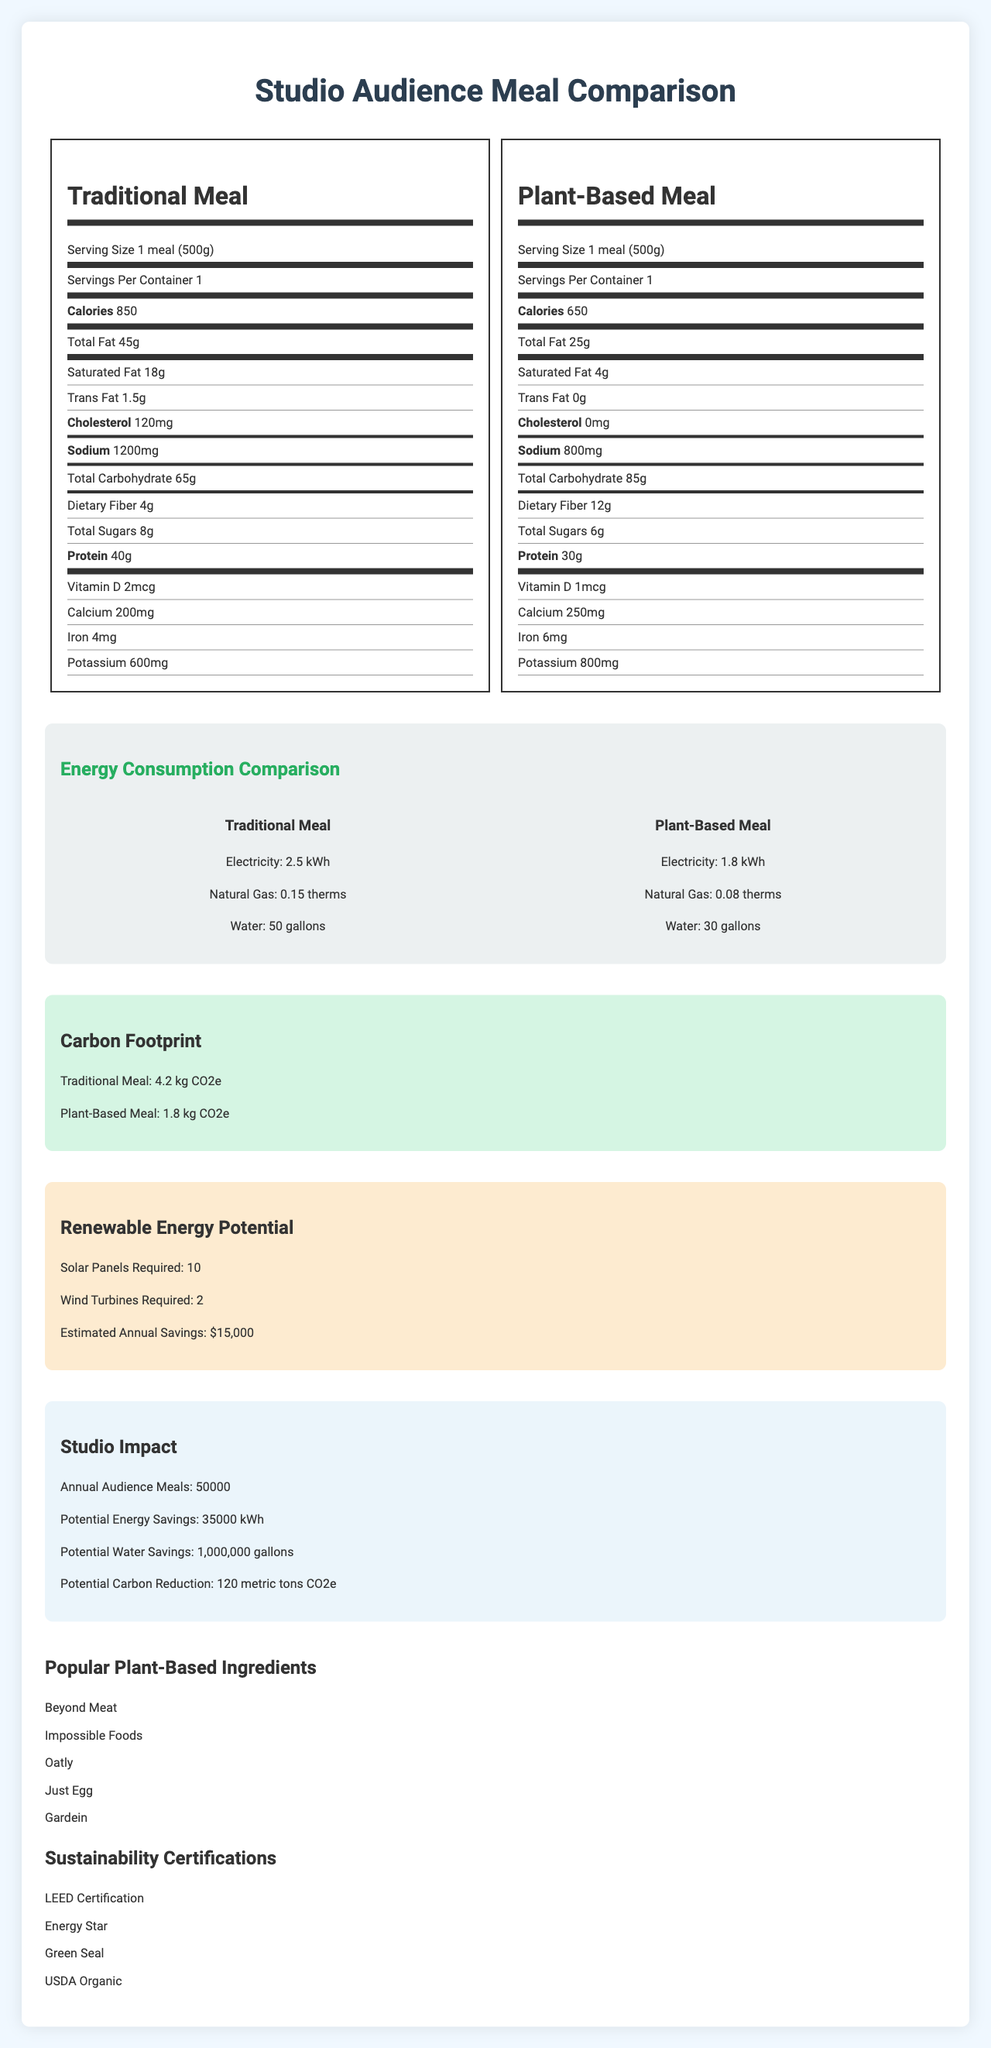what is the serving size for both meals? The serving size for both the traditional and plant-based meals is listed as 1 meal (500g) in the nutrition labels.
Answer: 1 meal (500g) how many calories are in the traditional meal? The calorie content for the traditional meal is listed as 850 in the nutrition label.
Answer: 850 how much sodium is in the plant-based meal? The plant-based meal contains 800 mg of sodium, as shown in the nutrition label.
Answer: 800 mg what is the carbon footprint of the traditional meal? The carbon footprint of the traditional meal is noted as 4.2 kg CO2e in the carbon footprint section.
Answer: 4.2 kg CO2e how much water is used to produce a traditional meal? The water usage for producing a traditional meal is listed as 50 gallons in the energy consumption comparison.
Answer: 50 gallons what is the total dietary fiber in the plant-based meal? The plant-based meal has a total dietary fiber content of 12 g, as shown on the nutrition label.
Answer: 12 g which meal has higher protein content, and by how much? The traditional meal has 40g of protein, while the plant-based meal has 30g, making the traditional meal higher in protein by 10g.
Answer: Traditional meal, by 10g which certification is not listed among the sustainability certifications? A. LEED Certification B. Energy Star C. Fair Trade D. Green Seal The sustainability certifications listed are LEED Certification, Energy Star, Green Seal, and USDA Organic, while Fair Trade is not listed.
Answer: C which component is higher in the traditional meal compared to the plant-based meal? A. Calcium B. Total Fat C. Dietary Fiber D. Cholesterol Cholesterol is 120 mg in the traditional meal compared to 0 mg in the plant-based meal, making it the higher component.
Answer: D does the plant-based meal contain any trans fat? The plant-based meal has 0 g of trans fat, as listed on the nutrition label.
Answer: No summarize the main idea of the document The document provides an in-depth comparison between traditional and plant-based meals for a studio audience, emphasizing nutritional benefits, energy and resource savings, and environmental impacts associated with plant-based options. Additionally, it details potential studio-wide impacts in terms of energy and water savings and carbon footprint reduction, while listing common plant-based ingredients and certifications.
Answer: The document compares traditional and plant-based studio audience meals in terms of nutritional content, energy consumption, and environmental impact. It highlights the benefits of plant-based meals, including lower calorie count, reduced fat and cholesterol, and higher dietary fiber. Additionally, it shows the lower energy and resource requirements for plant-based meal production and the significant reduction in carbon footprint. The document also outlines the potential energy, water savings, and carbon reduction impacts on the studio, and provides information on popular plant-based ingredients and sustainability certifications. how many annual audience meals does the studio serve? The studio serves 50,000 annual audience meals, as noted in the studio impact section.
Answer: 50,000 how many solar panels are required to meet renewable energy needs? The renewable energy potential section states that 10 solar panels are required.
Answer: 10 